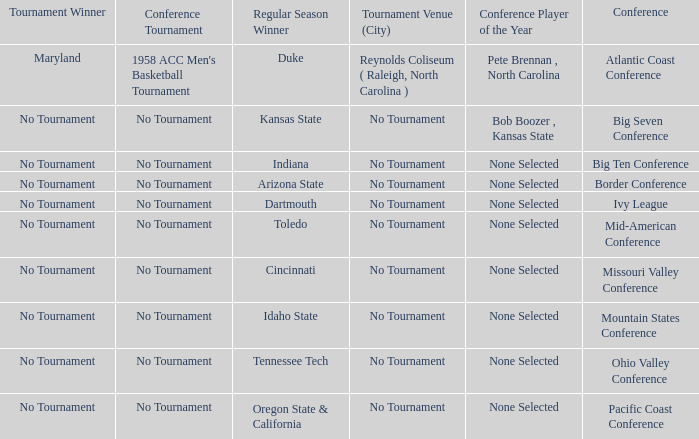Who is the tournament winner in the Atlantic Coast Conference? Maryland. 